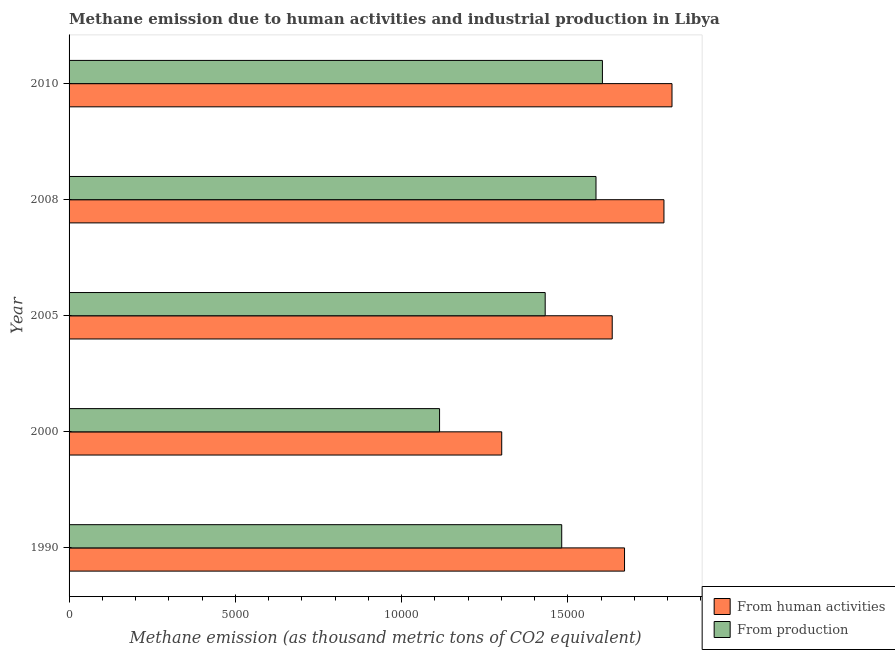How many groups of bars are there?
Your answer should be very brief. 5. How many bars are there on the 4th tick from the bottom?
Offer a terse response. 2. What is the amount of emissions from human activities in 2000?
Offer a terse response. 1.30e+04. Across all years, what is the maximum amount of emissions generated from industries?
Offer a terse response. 1.60e+04. Across all years, what is the minimum amount of emissions generated from industries?
Keep it short and to the point. 1.11e+04. In which year was the amount of emissions from human activities maximum?
Your response must be concise. 2010. What is the total amount of emissions from human activities in the graph?
Make the answer very short. 8.21e+04. What is the difference between the amount of emissions from human activities in 2005 and that in 2010?
Give a very brief answer. -1797.9. What is the difference between the amount of emissions generated from industries in 2005 and the amount of emissions from human activities in 2010?
Offer a terse response. -3813.6. What is the average amount of emissions from human activities per year?
Offer a terse response. 1.64e+04. In the year 2010, what is the difference between the amount of emissions from human activities and amount of emissions generated from industries?
Provide a succinct answer. 2092.3. What is the ratio of the amount of emissions from human activities in 2000 to that in 2010?
Make the answer very short. 0.72. Is the amount of emissions from human activities in 2008 less than that in 2010?
Your answer should be compact. Yes. Is the difference between the amount of emissions generated from industries in 1990 and 2000 greater than the difference between the amount of emissions from human activities in 1990 and 2000?
Your answer should be very brief. No. What is the difference between the highest and the second highest amount of emissions from human activities?
Offer a terse response. 242.2. What is the difference between the highest and the lowest amount of emissions from human activities?
Give a very brief answer. 5121.1. In how many years, is the amount of emissions from human activities greater than the average amount of emissions from human activities taken over all years?
Your answer should be very brief. 3. What does the 1st bar from the top in 2010 represents?
Ensure brevity in your answer.  From production. What does the 2nd bar from the bottom in 2008 represents?
Make the answer very short. From production. Does the graph contain any zero values?
Provide a short and direct response. No. Where does the legend appear in the graph?
Keep it short and to the point. Bottom right. How are the legend labels stacked?
Keep it short and to the point. Vertical. What is the title of the graph?
Provide a short and direct response. Methane emission due to human activities and industrial production in Libya. What is the label or title of the X-axis?
Your response must be concise. Methane emission (as thousand metric tons of CO2 equivalent). What is the label or title of the Y-axis?
Make the answer very short. Year. What is the Methane emission (as thousand metric tons of CO2 equivalent) in From human activities in 1990?
Provide a succinct answer. 1.67e+04. What is the Methane emission (as thousand metric tons of CO2 equivalent) in From production in 1990?
Offer a very short reply. 1.48e+04. What is the Methane emission (as thousand metric tons of CO2 equivalent) in From human activities in 2000?
Your answer should be very brief. 1.30e+04. What is the Methane emission (as thousand metric tons of CO2 equivalent) in From production in 2000?
Provide a short and direct response. 1.11e+04. What is the Methane emission (as thousand metric tons of CO2 equivalent) in From human activities in 2005?
Provide a succinct answer. 1.63e+04. What is the Methane emission (as thousand metric tons of CO2 equivalent) of From production in 2005?
Give a very brief answer. 1.43e+04. What is the Methane emission (as thousand metric tons of CO2 equivalent) in From human activities in 2008?
Ensure brevity in your answer.  1.79e+04. What is the Methane emission (as thousand metric tons of CO2 equivalent) of From production in 2008?
Your answer should be very brief. 1.58e+04. What is the Methane emission (as thousand metric tons of CO2 equivalent) in From human activities in 2010?
Offer a terse response. 1.81e+04. What is the Methane emission (as thousand metric tons of CO2 equivalent) of From production in 2010?
Provide a succinct answer. 1.60e+04. Across all years, what is the maximum Methane emission (as thousand metric tons of CO2 equivalent) in From human activities?
Your answer should be very brief. 1.81e+04. Across all years, what is the maximum Methane emission (as thousand metric tons of CO2 equivalent) in From production?
Your answer should be compact. 1.60e+04. Across all years, what is the minimum Methane emission (as thousand metric tons of CO2 equivalent) in From human activities?
Your answer should be compact. 1.30e+04. Across all years, what is the minimum Methane emission (as thousand metric tons of CO2 equivalent) of From production?
Provide a short and direct response. 1.11e+04. What is the total Methane emission (as thousand metric tons of CO2 equivalent) in From human activities in the graph?
Your answer should be very brief. 8.21e+04. What is the total Methane emission (as thousand metric tons of CO2 equivalent) of From production in the graph?
Provide a succinct answer. 7.22e+04. What is the difference between the Methane emission (as thousand metric tons of CO2 equivalent) in From human activities in 1990 and that in 2000?
Give a very brief answer. 3693.3. What is the difference between the Methane emission (as thousand metric tons of CO2 equivalent) of From production in 1990 and that in 2000?
Offer a terse response. 3673.7. What is the difference between the Methane emission (as thousand metric tons of CO2 equivalent) of From human activities in 1990 and that in 2005?
Offer a very short reply. 370.1. What is the difference between the Methane emission (as thousand metric tons of CO2 equivalent) in From production in 1990 and that in 2005?
Provide a succinct answer. 497.1. What is the difference between the Methane emission (as thousand metric tons of CO2 equivalent) in From human activities in 1990 and that in 2008?
Provide a succinct answer. -1185.6. What is the difference between the Methane emission (as thousand metric tons of CO2 equivalent) of From production in 1990 and that in 2008?
Provide a succinct answer. -1030.8. What is the difference between the Methane emission (as thousand metric tons of CO2 equivalent) of From human activities in 1990 and that in 2010?
Ensure brevity in your answer.  -1427.8. What is the difference between the Methane emission (as thousand metric tons of CO2 equivalent) in From production in 1990 and that in 2010?
Your response must be concise. -1224.2. What is the difference between the Methane emission (as thousand metric tons of CO2 equivalent) in From human activities in 2000 and that in 2005?
Ensure brevity in your answer.  -3323.2. What is the difference between the Methane emission (as thousand metric tons of CO2 equivalent) of From production in 2000 and that in 2005?
Your response must be concise. -3176.6. What is the difference between the Methane emission (as thousand metric tons of CO2 equivalent) of From human activities in 2000 and that in 2008?
Provide a succinct answer. -4878.9. What is the difference between the Methane emission (as thousand metric tons of CO2 equivalent) of From production in 2000 and that in 2008?
Your answer should be very brief. -4704.5. What is the difference between the Methane emission (as thousand metric tons of CO2 equivalent) of From human activities in 2000 and that in 2010?
Your response must be concise. -5121.1. What is the difference between the Methane emission (as thousand metric tons of CO2 equivalent) of From production in 2000 and that in 2010?
Provide a succinct answer. -4897.9. What is the difference between the Methane emission (as thousand metric tons of CO2 equivalent) of From human activities in 2005 and that in 2008?
Ensure brevity in your answer.  -1555.7. What is the difference between the Methane emission (as thousand metric tons of CO2 equivalent) in From production in 2005 and that in 2008?
Provide a short and direct response. -1527.9. What is the difference between the Methane emission (as thousand metric tons of CO2 equivalent) in From human activities in 2005 and that in 2010?
Provide a short and direct response. -1797.9. What is the difference between the Methane emission (as thousand metric tons of CO2 equivalent) in From production in 2005 and that in 2010?
Your answer should be compact. -1721.3. What is the difference between the Methane emission (as thousand metric tons of CO2 equivalent) in From human activities in 2008 and that in 2010?
Offer a very short reply. -242.2. What is the difference between the Methane emission (as thousand metric tons of CO2 equivalent) of From production in 2008 and that in 2010?
Provide a succinct answer. -193.4. What is the difference between the Methane emission (as thousand metric tons of CO2 equivalent) in From human activities in 1990 and the Methane emission (as thousand metric tons of CO2 equivalent) in From production in 2000?
Make the answer very short. 5562.4. What is the difference between the Methane emission (as thousand metric tons of CO2 equivalent) in From human activities in 1990 and the Methane emission (as thousand metric tons of CO2 equivalent) in From production in 2005?
Keep it short and to the point. 2385.8. What is the difference between the Methane emission (as thousand metric tons of CO2 equivalent) of From human activities in 1990 and the Methane emission (as thousand metric tons of CO2 equivalent) of From production in 2008?
Offer a terse response. 857.9. What is the difference between the Methane emission (as thousand metric tons of CO2 equivalent) of From human activities in 1990 and the Methane emission (as thousand metric tons of CO2 equivalent) of From production in 2010?
Offer a terse response. 664.5. What is the difference between the Methane emission (as thousand metric tons of CO2 equivalent) of From human activities in 2000 and the Methane emission (as thousand metric tons of CO2 equivalent) of From production in 2005?
Offer a very short reply. -1307.5. What is the difference between the Methane emission (as thousand metric tons of CO2 equivalent) in From human activities in 2000 and the Methane emission (as thousand metric tons of CO2 equivalent) in From production in 2008?
Your response must be concise. -2835.4. What is the difference between the Methane emission (as thousand metric tons of CO2 equivalent) in From human activities in 2000 and the Methane emission (as thousand metric tons of CO2 equivalent) in From production in 2010?
Offer a very short reply. -3028.8. What is the difference between the Methane emission (as thousand metric tons of CO2 equivalent) of From human activities in 2005 and the Methane emission (as thousand metric tons of CO2 equivalent) of From production in 2008?
Your response must be concise. 487.8. What is the difference between the Methane emission (as thousand metric tons of CO2 equivalent) of From human activities in 2005 and the Methane emission (as thousand metric tons of CO2 equivalent) of From production in 2010?
Keep it short and to the point. 294.4. What is the difference between the Methane emission (as thousand metric tons of CO2 equivalent) of From human activities in 2008 and the Methane emission (as thousand metric tons of CO2 equivalent) of From production in 2010?
Offer a very short reply. 1850.1. What is the average Methane emission (as thousand metric tons of CO2 equivalent) of From human activities per year?
Offer a very short reply. 1.64e+04. What is the average Methane emission (as thousand metric tons of CO2 equivalent) of From production per year?
Your answer should be very brief. 1.44e+04. In the year 1990, what is the difference between the Methane emission (as thousand metric tons of CO2 equivalent) in From human activities and Methane emission (as thousand metric tons of CO2 equivalent) in From production?
Ensure brevity in your answer.  1888.7. In the year 2000, what is the difference between the Methane emission (as thousand metric tons of CO2 equivalent) of From human activities and Methane emission (as thousand metric tons of CO2 equivalent) of From production?
Your response must be concise. 1869.1. In the year 2005, what is the difference between the Methane emission (as thousand metric tons of CO2 equivalent) in From human activities and Methane emission (as thousand metric tons of CO2 equivalent) in From production?
Your response must be concise. 2015.7. In the year 2008, what is the difference between the Methane emission (as thousand metric tons of CO2 equivalent) of From human activities and Methane emission (as thousand metric tons of CO2 equivalent) of From production?
Provide a short and direct response. 2043.5. In the year 2010, what is the difference between the Methane emission (as thousand metric tons of CO2 equivalent) of From human activities and Methane emission (as thousand metric tons of CO2 equivalent) of From production?
Offer a terse response. 2092.3. What is the ratio of the Methane emission (as thousand metric tons of CO2 equivalent) of From human activities in 1990 to that in 2000?
Offer a terse response. 1.28. What is the ratio of the Methane emission (as thousand metric tons of CO2 equivalent) of From production in 1990 to that in 2000?
Keep it short and to the point. 1.33. What is the ratio of the Methane emission (as thousand metric tons of CO2 equivalent) in From human activities in 1990 to that in 2005?
Ensure brevity in your answer.  1.02. What is the ratio of the Methane emission (as thousand metric tons of CO2 equivalent) of From production in 1990 to that in 2005?
Make the answer very short. 1.03. What is the ratio of the Methane emission (as thousand metric tons of CO2 equivalent) in From human activities in 1990 to that in 2008?
Keep it short and to the point. 0.93. What is the ratio of the Methane emission (as thousand metric tons of CO2 equivalent) of From production in 1990 to that in 2008?
Your answer should be very brief. 0.94. What is the ratio of the Methane emission (as thousand metric tons of CO2 equivalent) in From human activities in 1990 to that in 2010?
Provide a short and direct response. 0.92. What is the ratio of the Methane emission (as thousand metric tons of CO2 equivalent) of From production in 1990 to that in 2010?
Ensure brevity in your answer.  0.92. What is the ratio of the Methane emission (as thousand metric tons of CO2 equivalent) of From human activities in 2000 to that in 2005?
Offer a terse response. 0.8. What is the ratio of the Methane emission (as thousand metric tons of CO2 equivalent) of From production in 2000 to that in 2005?
Your response must be concise. 0.78. What is the ratio of the Methane emission (as thousand metric tons of CO2 equivalent) in From human activities in 2000 to that in 2008?
Offer a terse response. 0.73. What is the ratio of the Methane emission (as thousand metric tons of CO2 equivalent) of From production in 2000 to that in 2008?
Your answer should be compact. 0.7. What is the ratio of the Methane emission (as thousand metric tons of CO2 equivalent) in From human activities in 2000 to that in 2010?
Give a very brief answer. 0.72. What is the ratio of the Methane emission (as thousand metric tons of CO2 equivalent) of From production in 2000 to that in 2010?
Keep it short and to the point. 0.69. What is the ratio of the Methane emission (as thousand metric tons of CO2 equivalent) in From production in 2005 to that in 2008?
Make the answer very short. 0.9. What is the ratio of the Methane emission (as thousand metric tons of CO2 equivalent) in From human activities in 2005 to that in 2010?
Offer a terse response. 0.9. What is the ratio of the Methane emission (as thousand metric tons of CO2 equivalent) in From production in 2005 to that in 2010?
Keep it short and to the point. 0.89. What is the ratio of the Methane emission (as thousand metric tons of CO2 equivalent) of From human activities in 2008 to that in 2010?
Offer a terse response. 0.99. What is the ratio of the Methane emission (as thousand metric tons of CO2 equivalent) of From production in 2008 to that in 2010?
Keep it short and to the point. 0.99. What is the difference between the highest and the second highest Methane emission (as thousand metric tons of CO2 equivalent) of From human activities?
Your answer should be compact. 242.2. What is the difference between the highest and the second highest Methane emission (as thousand metric tons of CO2 equivalent) in From production?
Your response must be concise. 193.4. What is the difference between the highest and the lowest Methane emission (as thousand metric tons of CO2 equivalent) of From human activities?
Your response must be concise. 5121.1. What is the difference between the highest and the lowest Methane emission (as thousand metric tons of CO2 equivalent) of From production?
Offer a terse response. 4897.9. 